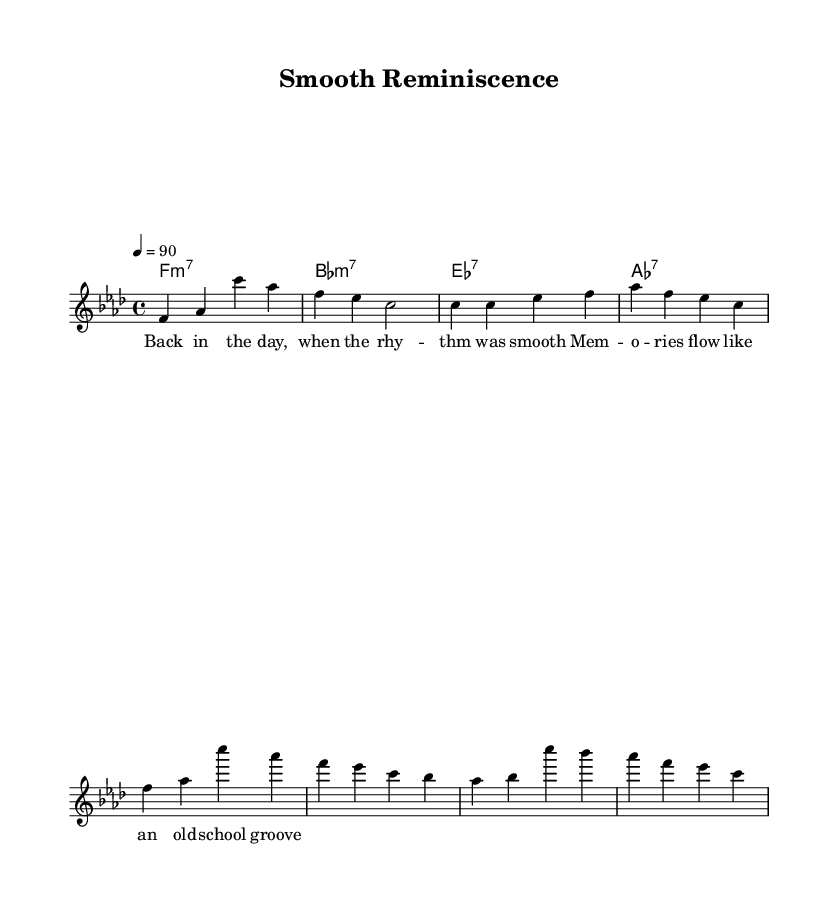What is the key signature of this music? The key signature is indicated by the arrangement of accidentals at the beginning of the staff. In this case, it's F minor, which has four flats: B♭, E♭, A♭, and D♭.
Answer: F minor What is the time signature of this music? The time signature is found as a fraction at the beginning of the staff, which shows how many beats are in each measure. Here, it is written as 4/4, indicating that there are four beats in each measure and a quarter note receives one beat.
Answer: 4/4 What is the tempo marking for this piece? The tempo marking is provided in the score as a number, indicating the speed of the piece. It shows that beats per minute (BPM) is set to 90, which provides a moderate pace for the rhythm.
Answer: 90 How many measures are in the verse section? The verse section consists of the series of notes after the introductory phrase. After counting the groupings of notes from the melody line, it is evident that there is a total of 2 measures for that section.
Answer: 2 Which chord is used during the chorus? The chorus contains a series of harmonies that accompany the melody. The first chord encountered in the chorus is F major, which is clearly specified in the harmonies section during this part of the song.
Answer: F major What type of influence is evident in this rap piece? The lyrical content and musical structure display influences from smooth R&B styles, which can be recognized in the melodic flow and rhythm that adds a smooth feel to the piece.
Answer: Smooth R&B What is the function of the bridge in this music? The bridge is a transitional element that connects different parts of the song, often providing contrast. In the sheet music, the bridge section introduces A♭, B♭, C, and helps to build anticipation before returning to the chorus.
Answer: Transition 